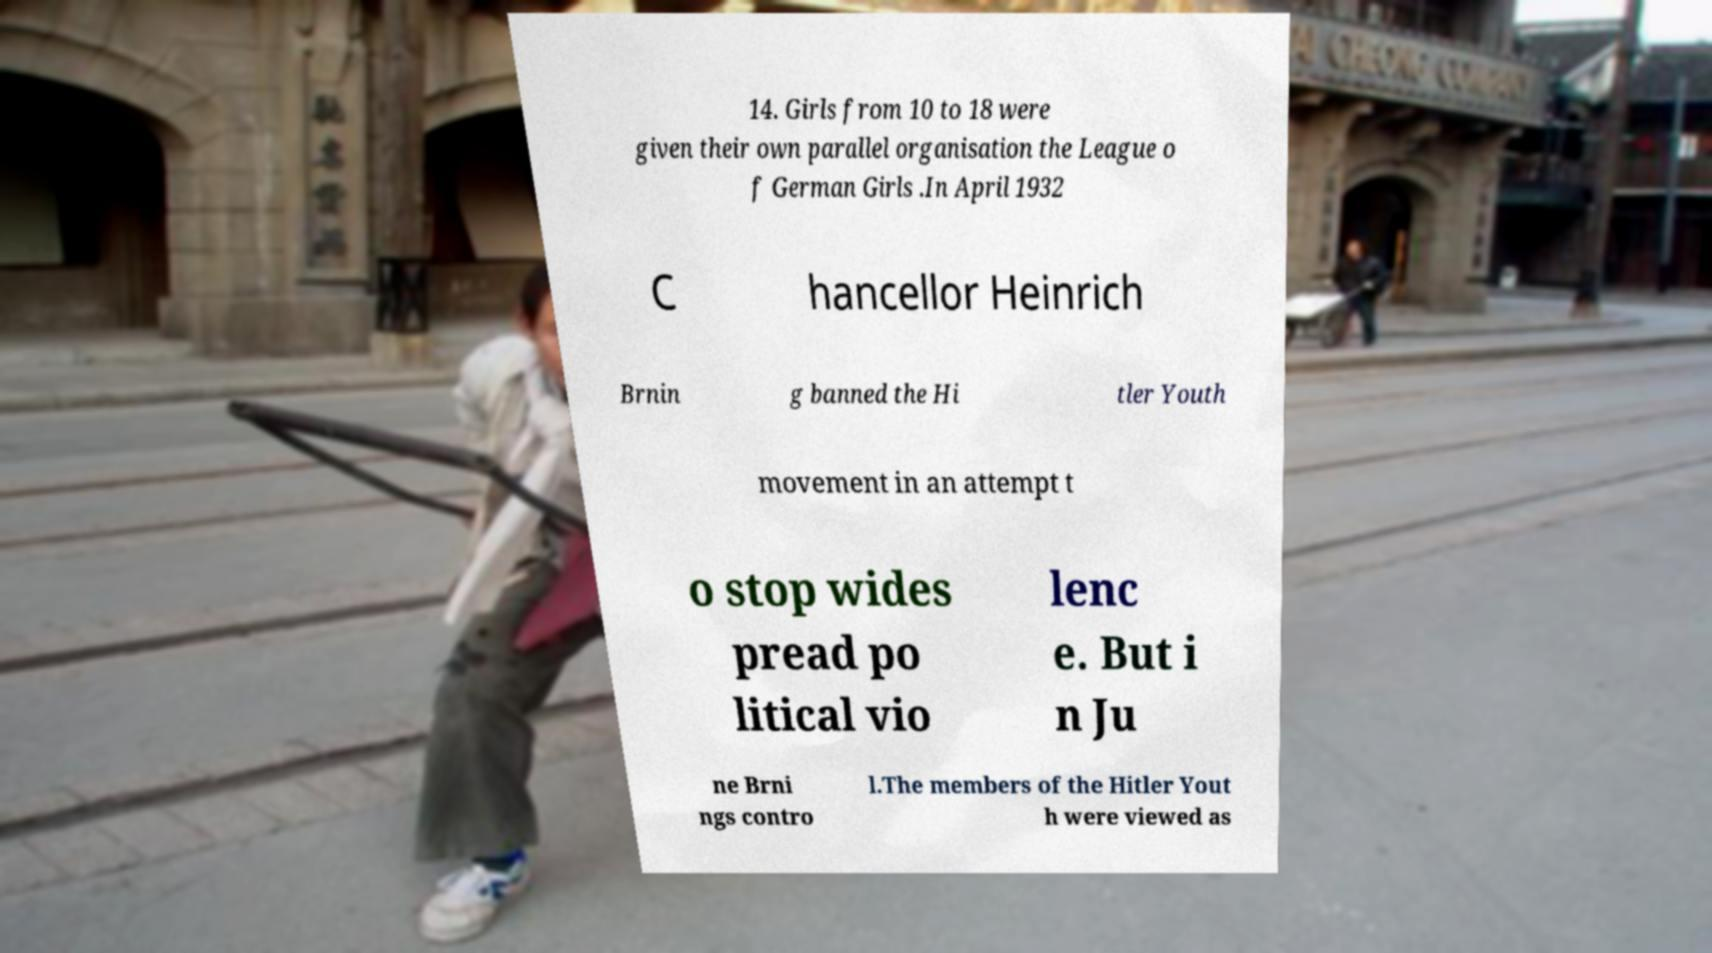Please read and relay the text visible in this image. What does it say? 14. Girls from 10 to 18 were given their own parallel organisation the League o f German Girls .In April 1932 C hancellor Heinrich Brnin g banned the Hi tler Youth movement in an attempt t o stop wides pread po litical vio lenc e. But i n Ju ne Brni ngs contro l.The members of the Hitler Yout h were viewed as 